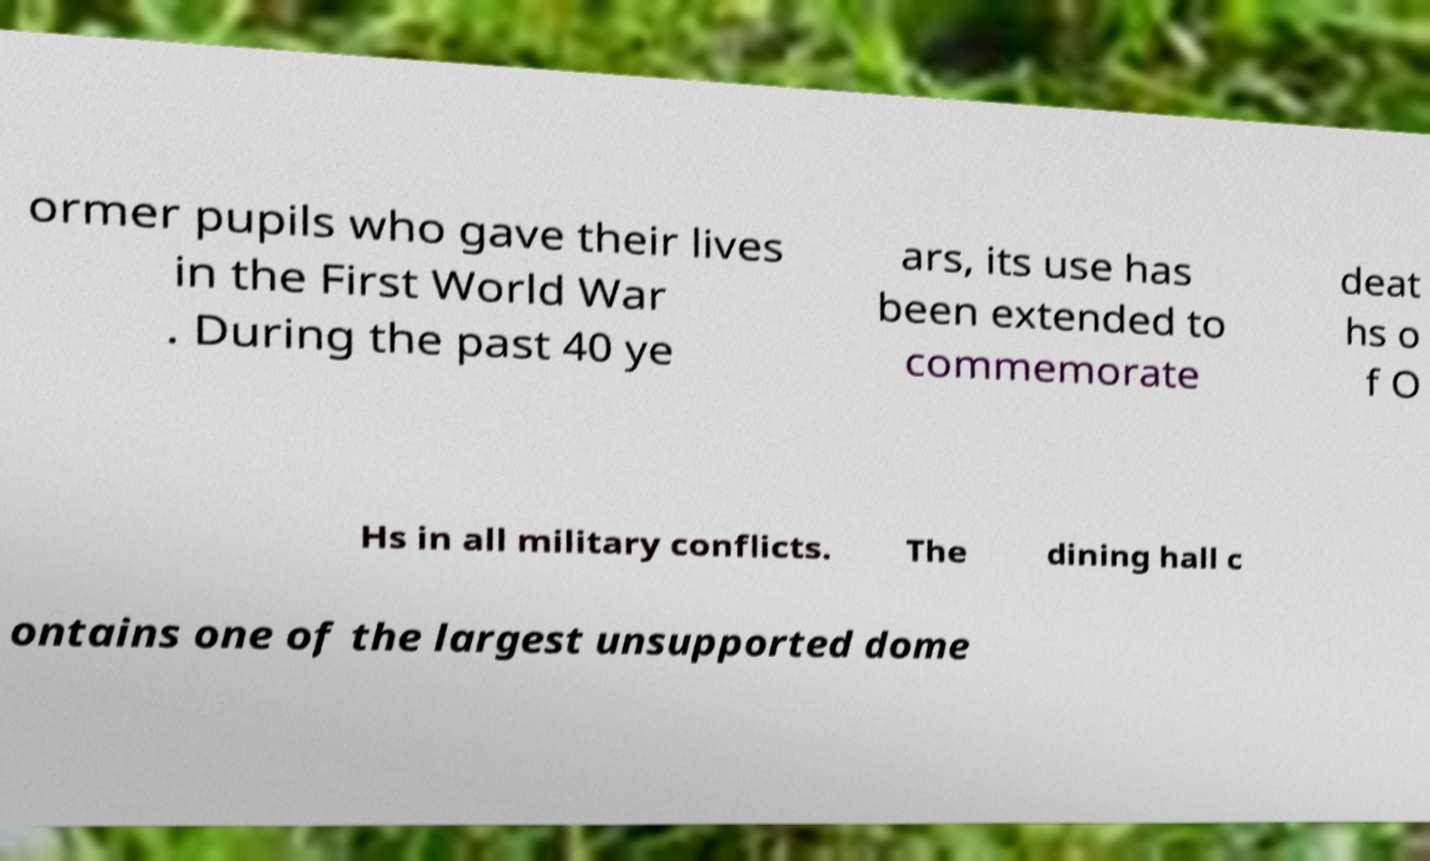Could you extract and type out the text from this image? ormer pupils who gave their lives in the First World War . During the past 40 ye ars, its use has been extended to commemorate deat hs o f O Hs in all military conflicts. The dining hall c ontains one of the largest unsupported dome 